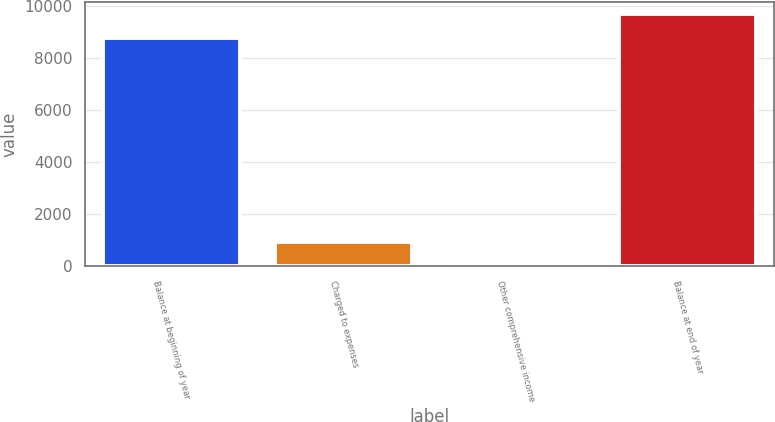Convert chart. <chart><loc_0><loc_0><loc_500><loc_500><bar_chart><fcel>Balance at beginning of year<fcel>Charged to expenses<fcel>Other comprehensive income<fcel>Balance at end of year<nl><fcel>8755<fcel>917.4<fcel>13<fcel>9659.4<nl></chart> 